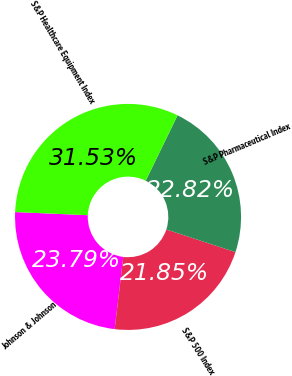Convert chart. <chart><loc_0><loc_0><loc_500><loc_500><pie_chart><fcel>Johnson & Johnson<fcel>S&P 500 Index<fcel>S&P Pharmaceutical Index<fcel>S&P Healthcare Equipment Index<nl><fcel>23.79%<fcel>21.85%<fcel>22.82%<fcel>31.53%<nl></chart> 